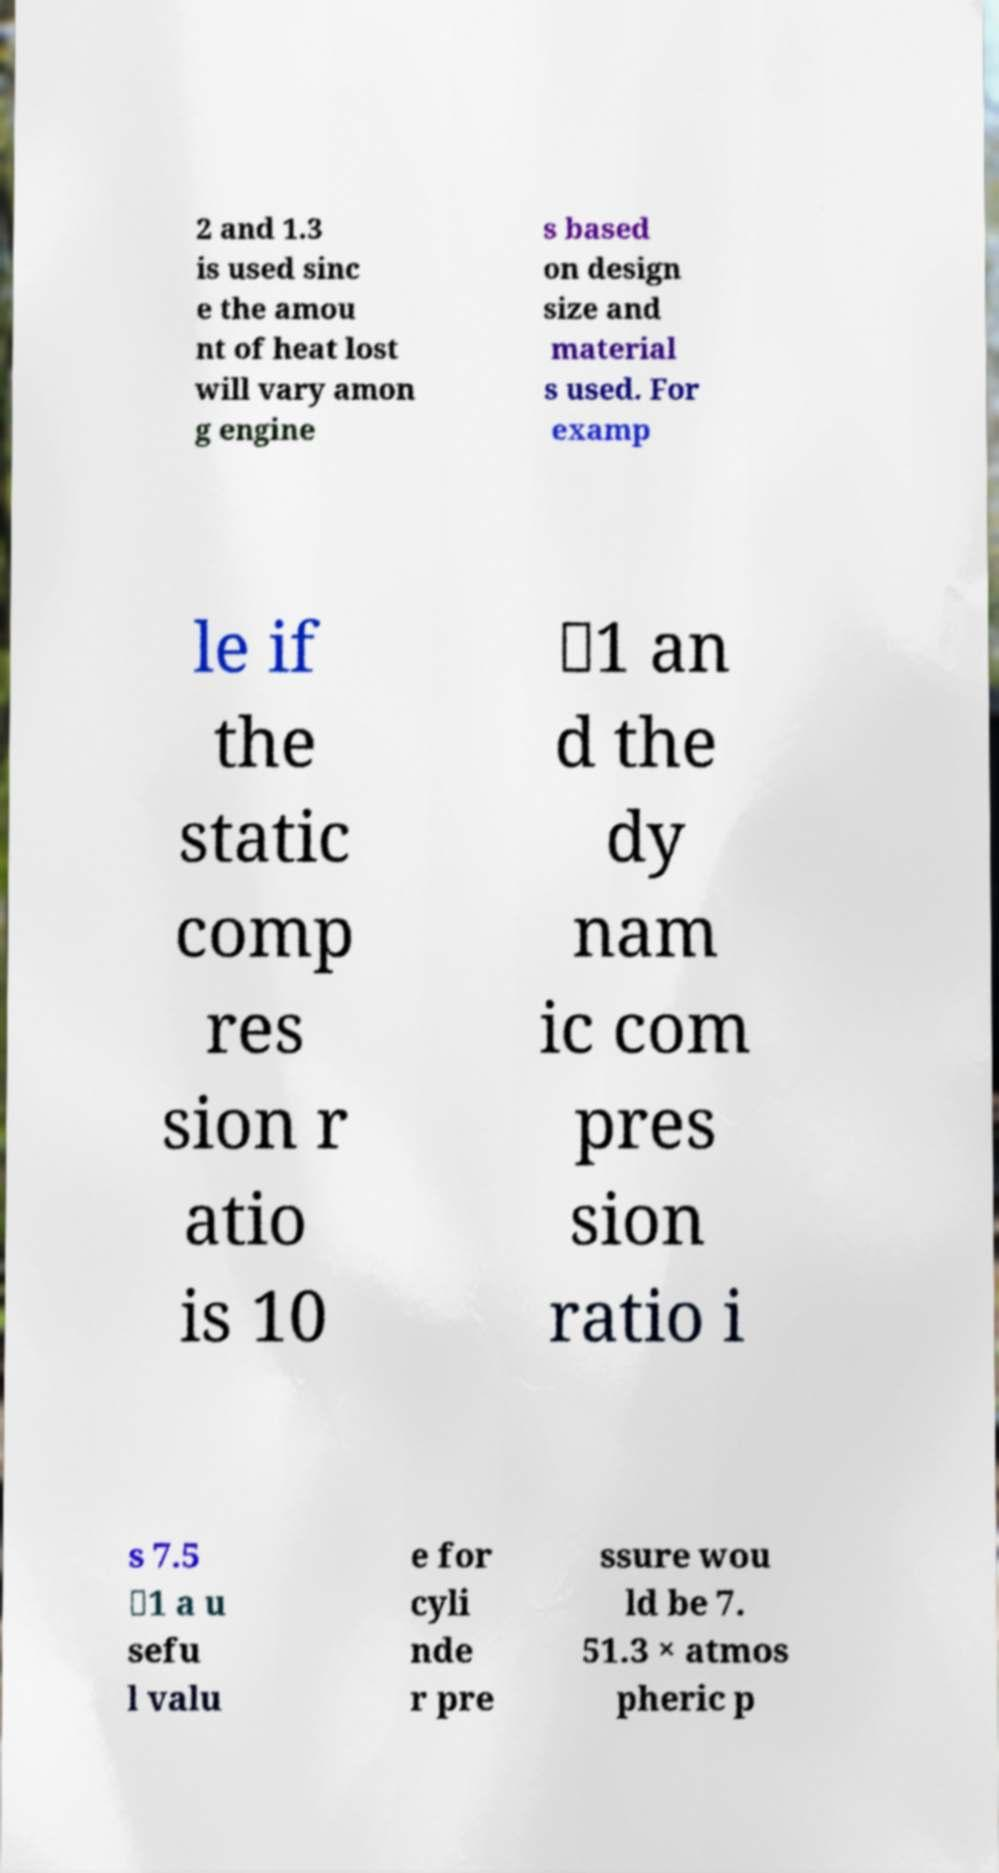Please read and relay the text visible in this image. What does it say? 2 and 1.3 is used sinc e the amou nt of heat lost will vary amon g engine s based on design size and material s used. For examp le if the static comp res sion r atio is 10 ∶1 an d the dy nam ic com pres sion ratio i s 7.5 ∶1 a u sefu l valu e for cyli nde r pre ssure wou ld be 7. 51.3 × atmos pheric p 